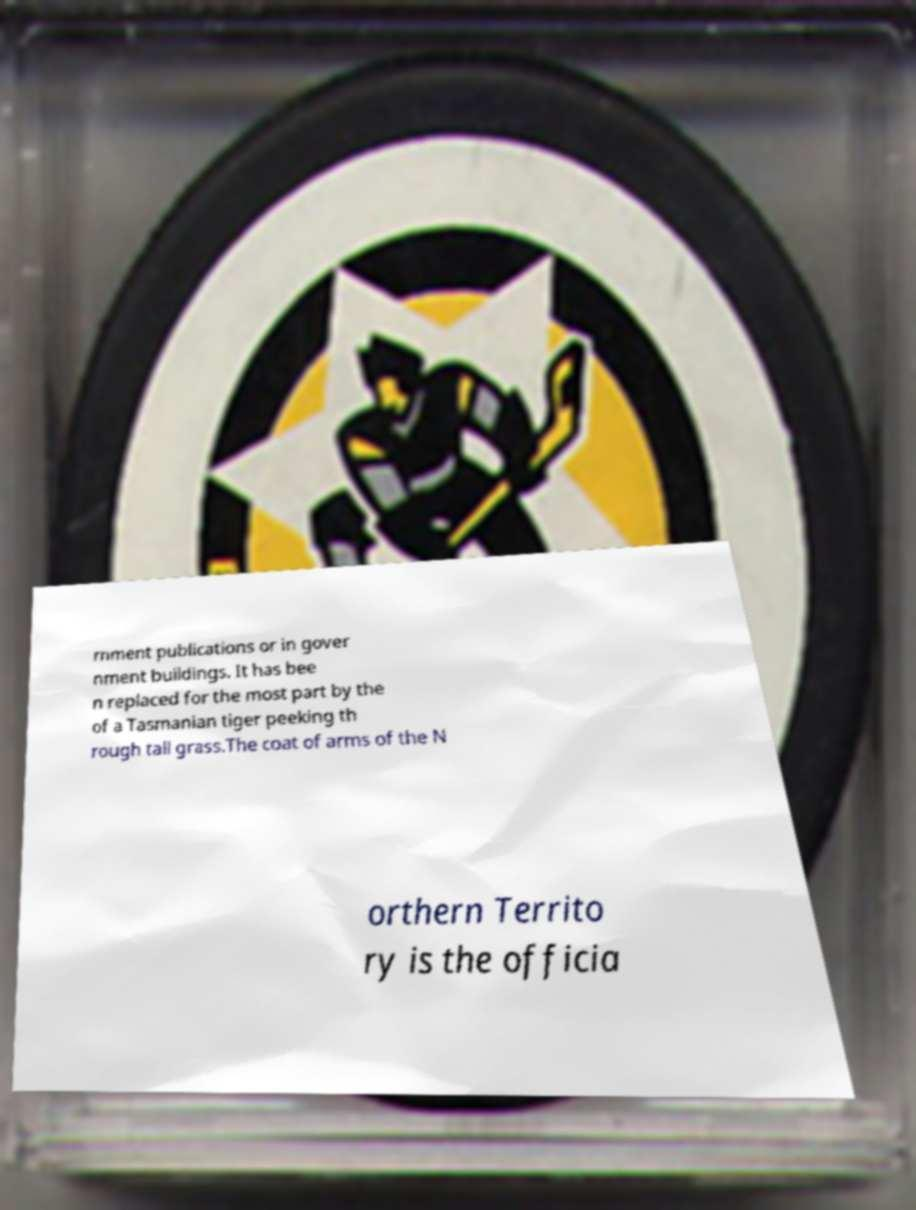There's text embedded in this image that I need extracted. Can you transcribe it verbatim? rnment publications or in gover nment buildings. It has bee n replaced for the most part by the of a Tasmanian tiger peeking th rough tall grass.The coat of arms of the N orthern Territo ry is the officia 